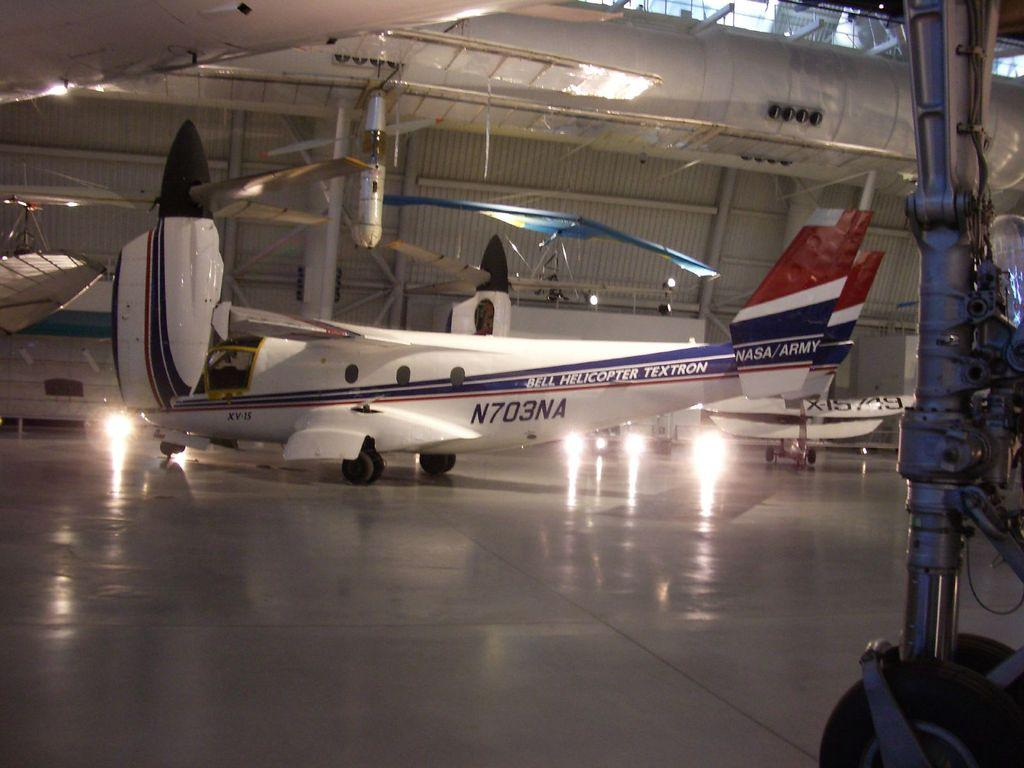What is the main subject of the image? The main subject of the image is an aircraft. What is the color of the aircraft? The aircraft is white in color. What can be seen in the background of the image? There are grills visible in the background of the image. What else is visible in the image besides the aircraft and grills? There are lights visible in the image. How many pigs are visible in the image? There are no pigs present in the image. What type of currency is being used in the image? There is no reference to any currency or monetary transaction in the image. 